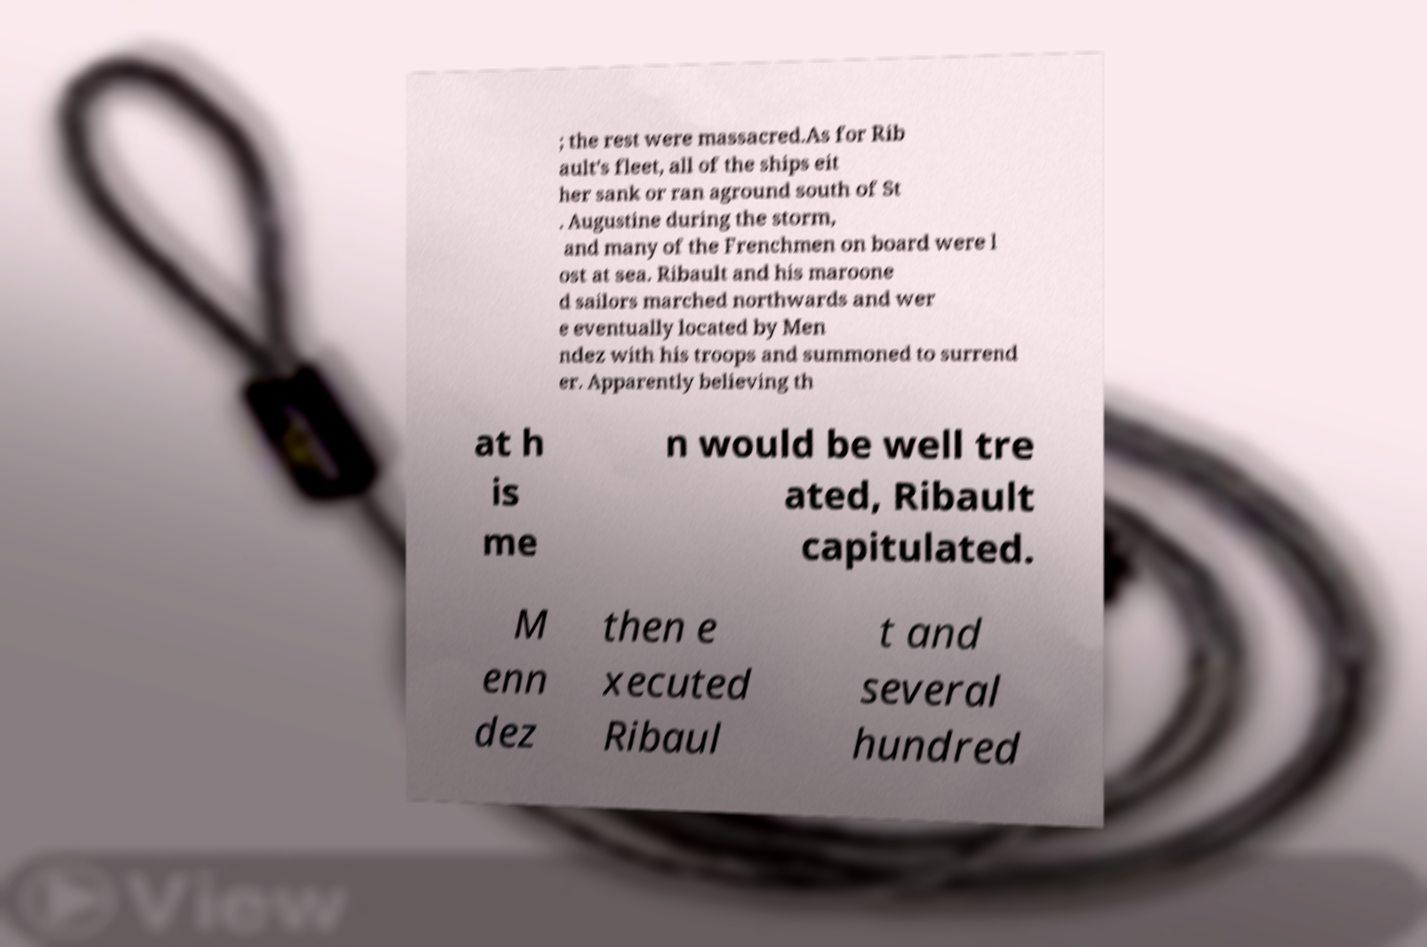What messages or text are displayed in this image? I need them in a readable, typed format. ; the rest were massacred.As for Rib ault's fleet, all of the ships eit her sank or ran aground south of St . Augustine during the storm, and many of the Frenchmen on board were l ost at sea. Ribault and his maroone d sailors marched northwards and wer e eventually located by Men ndez with his troops and summoned to surrend er. Apparently believing th at h is me n would be well tre ated, Ribault capitulated. M enn dez then e xecuted Ribaul t and several hundred 